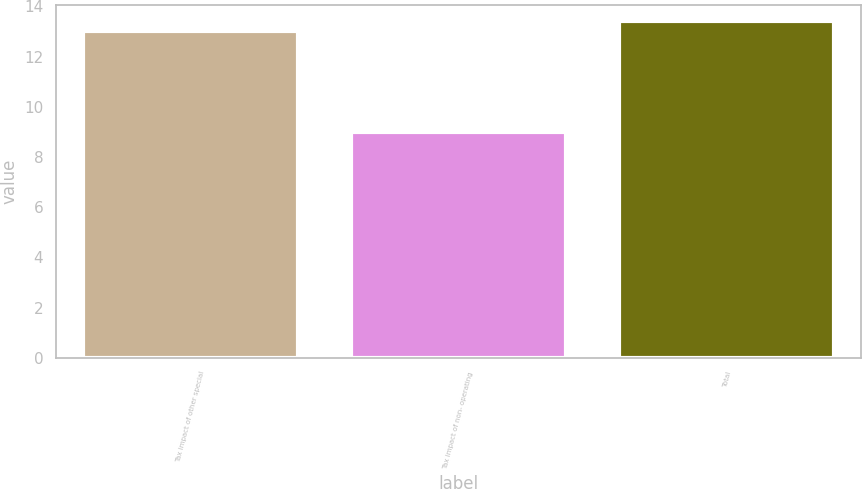<chart> <loc_0><loc_0><loc_500><loc_500><bar_chart><fcel>Tax impact of other special<fcel>Tax impact of non- operating<fcel>Total<nl><fcel>13<fcel>9<fcel>13.4<nl></chart> 